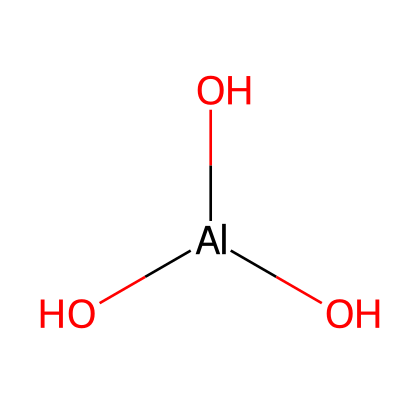how many oxygen atoms are present? In the SMILES representation [Al](O)(O)O, the presence of three O atoms indicates there are three oxygen atoms.
Answer: three what is the central atom in this chemical structure? The central atom is the aluminum atom, which is indicated by the [Al] notation in the SMILES string.
Answer: aluminum what type of chemical bond connects the aluminum and oxygen atoms? The bond connecting the aluminum atom to the oxygen atoms is a coordinate covalent bond, as aluminum shares its electrons with oxygen atoms in an unusual manner.
Answer: coordinate covalent bond how many hydroxyl groups are present? The structure contains three –OH groups (noted as the "(O)" connections in the SMILES), indicating three hydroxyl groups attached to the aluminum atom.
Answer: three what functional groups are present in this chemical? The presence of three hydroxyl (–OH) groups indicates that the functional groups present are hydroxyl groups, which are characteristic of alcohols.
Answer: hydroxyl is this chemical likely to be soluble in water? Hydroxyl groups increase polarity, suggesting that the compound is likely to be soluble in water due to hydrogen bonding with water molecules.
Answer: yes 